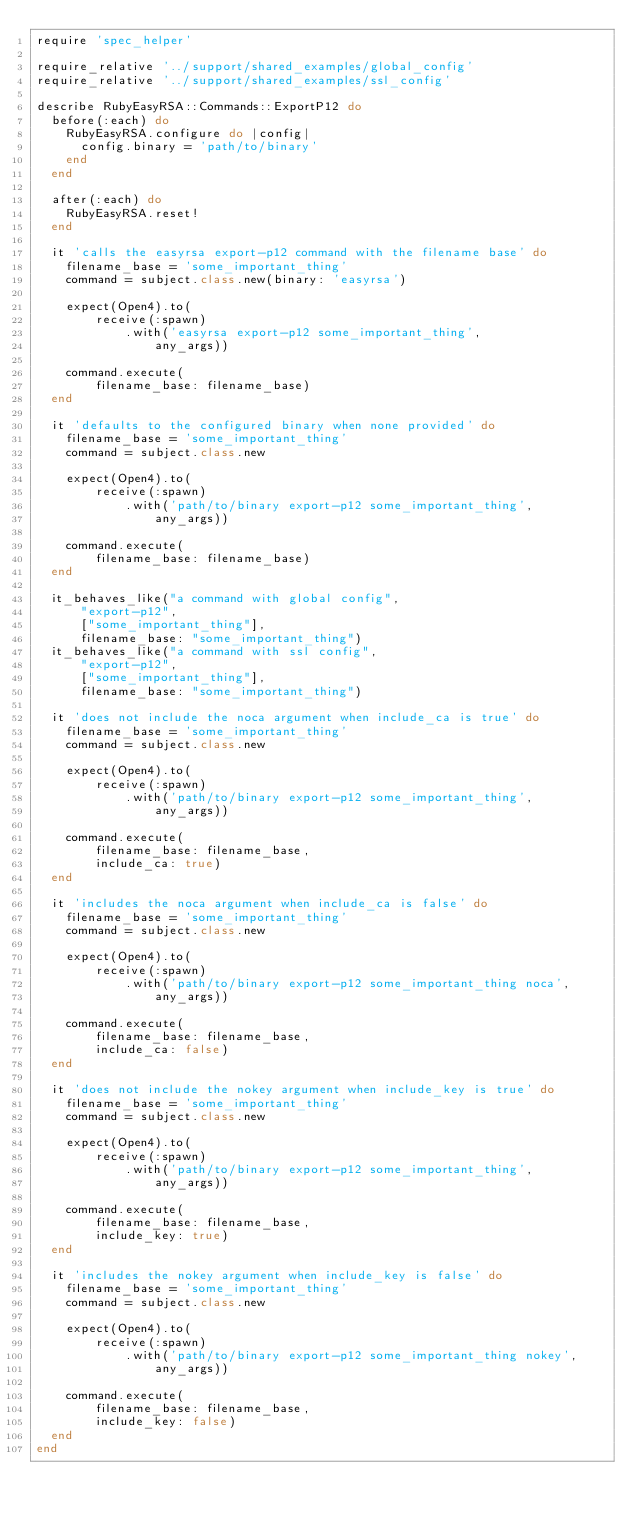<code> <loc_0><loc_0><loc_500><loc_500><_Ruby_>require 'spec_helper'

require_relative '../support/shared_examples/global_config'
require_relative '../support/shared_examples/ssl_config'

describe RubyEasyRSA::Commands::ExportP12 do
  before(:each) do
    RubyEasyRSA.configure do |config|
      config.binary = 'path/to/binary'
    end
  end

  after(:each) do
    RubyEasyRSA.reset!
  end

  it 'calls the easyrsa export-p12 command with the filename base' do
    filename_base = 'some_important_thing'
    command = subject.class.new(binary: 'easyrsa')

    expect(Open4).to(
        receive(:spawn)
            .with('easyrsa export-p12 some_important_thing',
                any_args))

    command.execute(
        filename_base: filename_base)
  end

  it 'defaults to the configured binary when none provided' do
    filename_base = 'some_important_thing'
    command = subject.class.new

    expect(Open4).to(
        receive(:spawn)
            .with('path/to/binary export-p12 some_important_thing',
                any_args))

    command.execute(
        filename_base: filename_base)
  end

  it_behaves_like("a command with global config",
      "export-p12",
      ["some_important_thing"],
      filename_base: "some_important_thing")
  it_behaves_like("a command with ssl config",
      "export-p12",
      ["some_important_thing"],
      filename_base: "some_important_thing")

  it 'does not include the noca argument when include_ca is true' do
    filename_base = 'some_important_thing'
    command = subject.class.new

    expect(Open4).to(
        receive(:spawn)
            .with('path/to/binary export-p12 some_important_thing',
                any_args))

    command.execute(
        filename_base: filename_base,
        include_ca: true)
  end

  it 'includes the noca argument when include_ca is false' do
    filename_base = 'some_important_thing'
    command = subject.class.new

    expect(Open4).to(
        receive(:spawn)
            .with('path/to/binary export-p12 some_important_thing noca',
                any_args))

    command.execute(
        filename_base: filename_base,
        include_ca: false)
  end

  it 'does not include the nokey argument when include_key is true' do
    filename_base = 'some_important_thing'
    command = subject.class.new

    expect(Open4).to(
        receive(:spawn)
            .with('path/to/binary export-p12 some_important_thing',
                any_args))

    command.execute(
        filename_base: filename_base,
        include_key: true)
  end

  it 'includes the nokey argument when include_key is false' do
    filename_base = 'some_important_thing'
    command = subject.class.new

    expect(Open4).to(
        receive(:spawn)
            .with('path/to/binary export-p12 some_important_thing nokey',
                any_args))

    command.execute(
        filename_base: filename_base,
        include_key: false)
  end
end
</code> 